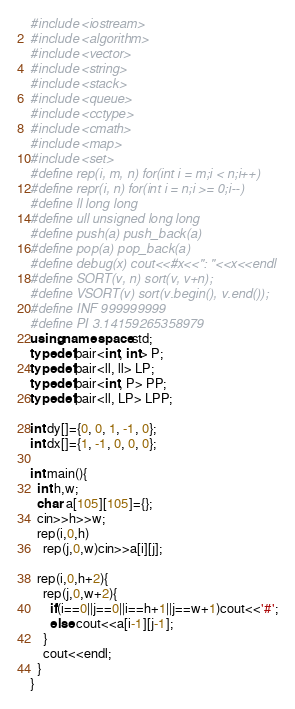<code> <loc_0><loc_0><loc_500><loc_500><_C++_>#include <iostream>
#include <algorithm>
#include <vector>
#include <string>
#include <stack>
#include <queue>
#include <cctype>
#include <cmath>
#include <map>
#include <set>
#define rep(i, m, n) for(int i = m;i < n;i++)
#define repr(i, n) for(int i = n;i >= 0;i--)
#define ll long long
#define ull unsigned long long
#define push(a) push_back(a)
#define pop(a) pop_back(a)
#define debug(x) cout<<#x<<": "<<x<<endl
#define SORT(v, n) sort(v, v+n);
#define VSORT(v) sort(v.begin(), v.end());
#define INF 999999999
#define PI 3.14159265358979
using namespace std;
typedef pair<int, int> P;
typedef pair<ll, ll> LP;
typedef pair<int, P> PP;
typedef pair<ll, LP> LPP;

int dy[]={0, 0, 1, -1, 0};
int dx[]={1, -1, 0, 0, 0};

int main(){
  int h,w;
  char a[105][105]={};
  cin>>h>>w;
  rep(i,0,h)
    rep(j,0,w)cin>>a[i][j];

  rep(i,0,h+2){
    rep(j,0,w+2){
      if(i==0||j==0||i==h+1||j==w+1)cout<<'#';
      else cout<<a[i-1][j-1];
    }
    cout<<endl;
  }
}</code> 